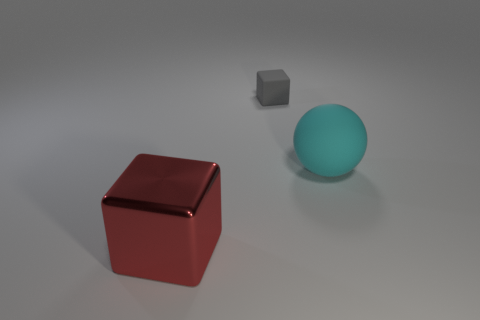Add 1 big blocks. How many objects exist? 4 Subtract 1 blocks. How many blocks are left? 1 Subtract all spheres. How many objects are left? 2 Subtract all large cyan cylinders. Subtract all big things. How many objects are left? 1 Add 1 big balls. How many big balls are left? 2 Add 1 matte cubes. How many matte cubes exist? 2 Subtract 0 gray cylinders. How many objects are left? 3 Subtract all yellow balls. Subtract all purple cylinders. How many balls are left? 1 